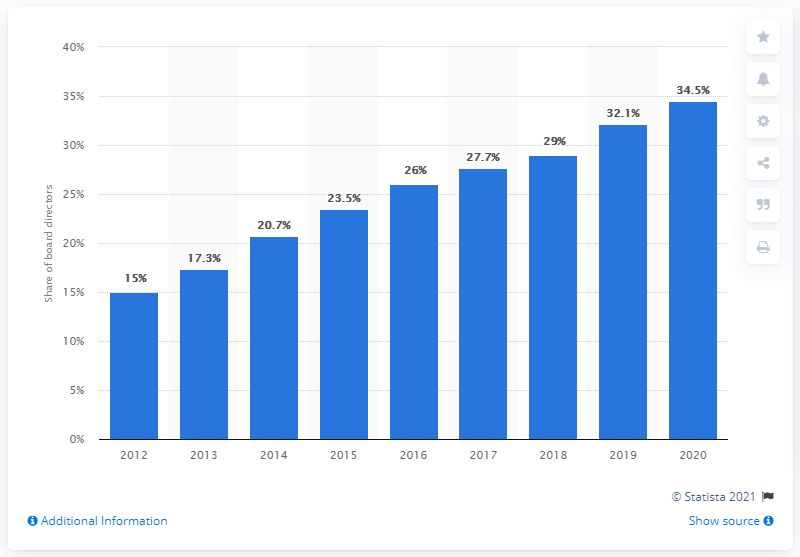Indicate a few pertinent items in this graphic. As of June 2020, it was reported that 34.5% of women held directorships in the UK. 